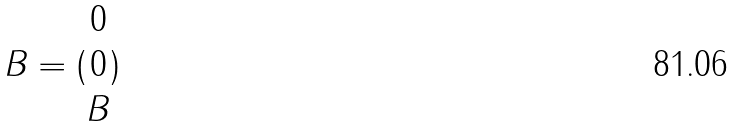Convert formula to latex. <formula><loc_0><loc_0><loc_500><loc_500>B = ( \begin{matrix} 0 \\ 0 \\ B \end{matrix} )</formula> 